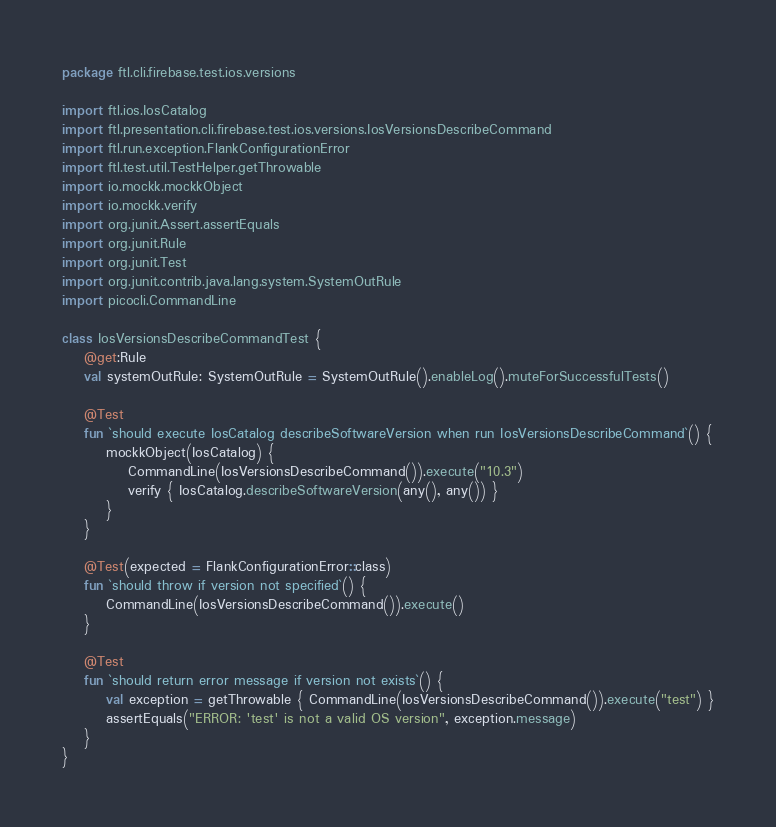<code> <loc_0><loc_0><loc_500><loc_500><_Kotlin_>package ftl.cli.firebase.test.ios.versions

import ftl.ios.IosCatalog
import ftl.presentation.cli.firebase.test.ios.versions.IosVersionsDescribeCommand
import ftl.run.exception.FlankConfigurationError
import ftl.test.util.TestHelper.getThrowable
import io.mockk.mockkObject
import io.mockk.verify
import org.junit.Assert.assertEquals
import org.junit.Rule
import org.junit.Test
import org.junit.contrib.java.lang.system.SystemOutRule
import picocli.CommandLine

class IosVersionsDescribeCommandTest {
    @get:Rule
    val systemOutRule: SystemOutRule = SystemOutRule().enableLog().muteForSuccessfulTests()

    @Test
    fun `should execute IosCatalog describeSoftwareVersion when run IosVersionsDescribeCommand`() {
        mockkObject(IosCatalog) {
            CommandLine(IosVersionsDescribeCommand()).execute("10.3")
            verify { IosCatalog.describeSoftwareVersion(any(), any()) }
        }
    }

    @Test(expected = FlankConfigurationError::class)
    fun `should throw if version not specified`() {
        CommandLine(IosVersionsDescribeCommand()).execute()
    }

    @Test
    fun `should return error message if version not exists`() {
        val exception = getThrowable { CommandLine(IosVersionsDescribeCommand()).execute("test") }
        assertEquals("ERROR: 'test' is not a valid OS version", exception.message)
    }
}
</code> 